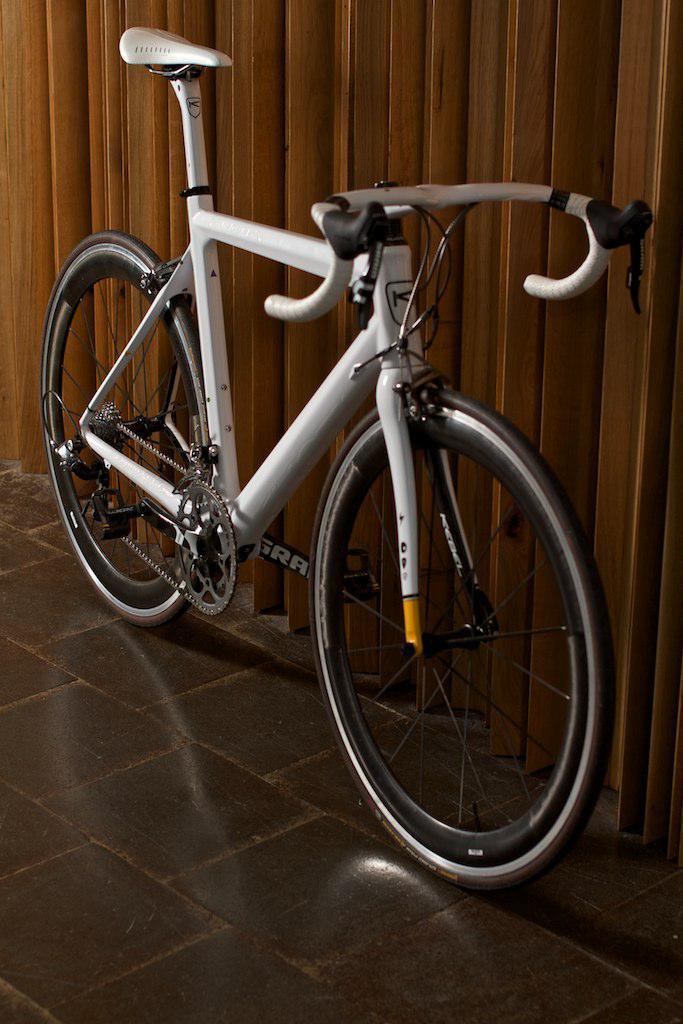Could you give a brief overview of what you see in this image? In this image we can see a bicycle on the floor. 